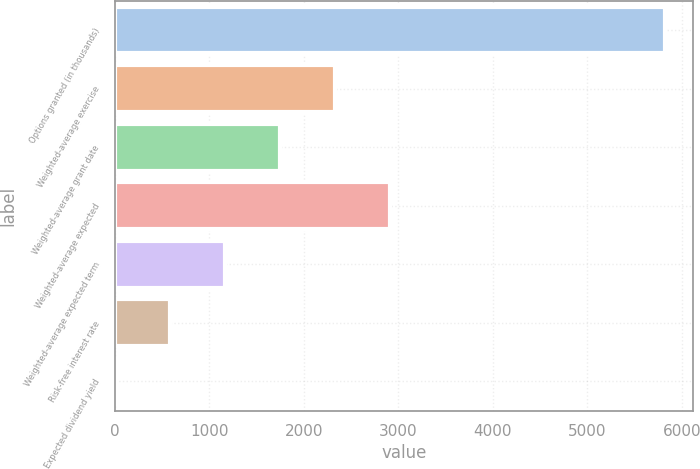Convert chart. <chart><loc_0><loc_0><loc_500><loc_500><bar_chart><fcel>Options granted (in thousands)<fcel>Weighted-average exercise<fcel>Weighted-average grant date<fcel>Weighted-average expected<fcel>Weighted-average expected term<fcel>Risk-free interest rate<fcel>Expected dividend yield<nl><fcel>5827<fcel>2332.24<fcel>1749.78<fcel>2914.7<fcel>1167.32<fcel>584.86<fcel>2.4<nl></chart> 